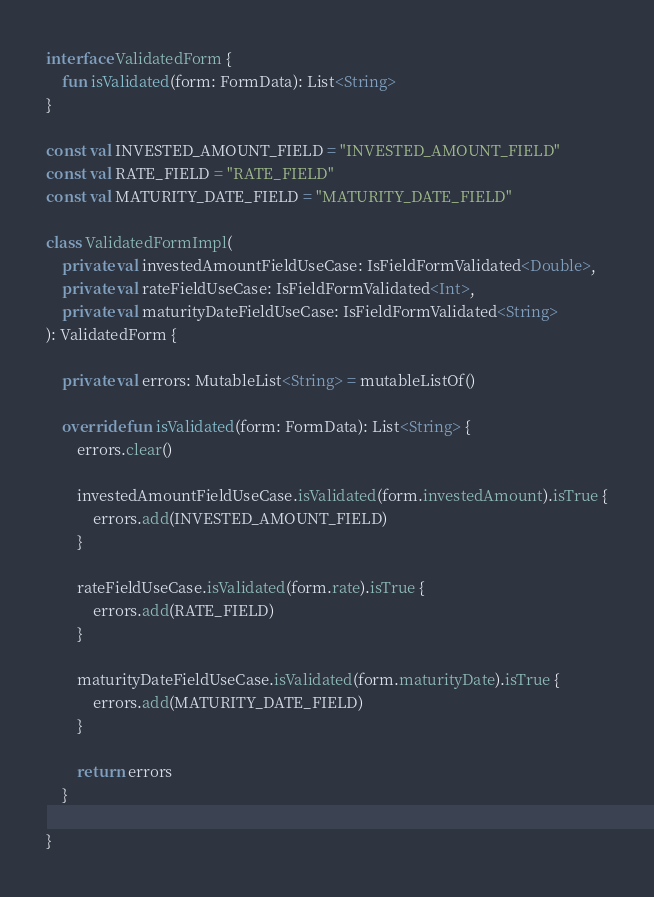<code> <loc_0><loc_0><loc_500><loc_500><_Kotlin_>
interface ValidatedForm {
    fun isValidated(form: FormData): List<String>
}

const val INVESTED_AMOUNT_FIELD = "INVESTED_AMOUNT_FIELD"
const val RATE_FIELD = "RATE_FIELD"
const val MATURITY_DATE_FIELD = "MATURITY_DATE_FIELD"

class ValidatedFormImpl(
    private val investedAmountFieldUseCase: IsFieldFormValidated<Double>,
    private val rateFieldUseCase: IsFieldFormValidated<Int>,
    private val maturityDateFieldUseCase: IsFieldFormValidated<String>
): ValidatedForm {

    private val errors: MutableList<String> = mutableListOf()

    override fun isValidated(form: FormData): List<String> {
        errors.clear()

        investedAmountFieldUseCase.isValidated(form.investedAmount).isTrue {
            errors.add(INVESTED_AMOUNT_FIELD)
        }

        rateFieldUseCase.isValidated(form.rate).isTrue {
            errors.add(RATE_FIELD)
        }

        maturityDateFieldUseCase.isValidated(form.maturityDate).isTrue {
            errors.add(MATURITY_DATE_FIELD)
        }

        return errors
    }

}
</code> 